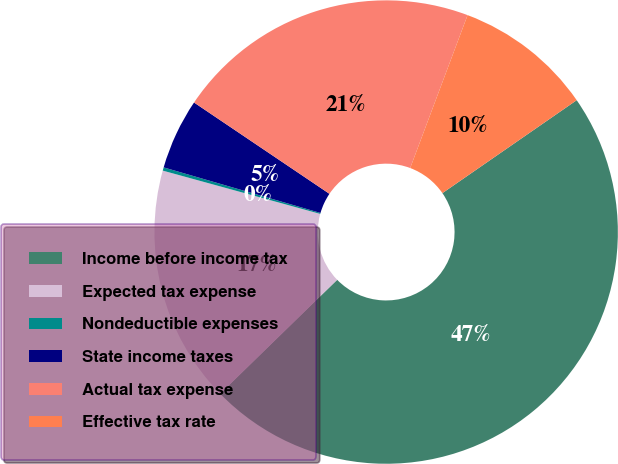Convert chart. <chart><loc_0><loc_0><loc_500><loc_500><pie_chart><fcel>Income before income tax<fcel>Expected tax expense<fcel>Nondeductible expenses<fcel>State income taxes<fcel>Actual tax expense<fcel>Effective tax rate<nl><fcel>47.34%<fcel>16.56%<fcel>0.23%<fcel>4.94%<fcel>21.27%<fcel>9.65%<nl></chart> 